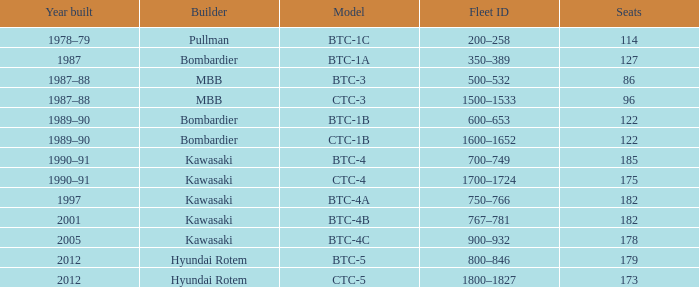For the train built in 2012 with less than 179 seats, what is the Fleet ID? 1800–1827. Would you be able to parse every entry in this table? {'header': ['Year built', 'Builder', 'Model', 'Fleet ID', 'Seats'], 'rows': [['1978–79', 'Pullman', 'BTC-1C', '200–258', '114'], ['1987', 'Bombardier', 'BTC-1A', '350–389', '127'], ['1987–88', 'MBB', 'BTC-3', '500–532', '86'], ['1987–88', 'MBB', 'CTC-3', '1500–1533', '96'], ['1989–90', 'Bombardier', 'BTC-1B', '600–653', '122'], ['1989–90', 'Bombardier', 'CTC-1B', '1600–1652', '122'], ['1990–91', 'Kawasaki', 'BTC-4', '700–749', '185'], ['1990–91', 'Kawasaki', 'CTC-4', '1700–1724', '175'], ['1997', 'Kawasaki', 'BTC-4A', '750–766', '182'], ['2001', 'Kawasaki', 'BTC-4B', '767–781', '182'], ['2005', 'Kawasaki', 'BTC-4C', '900–932', '178'], ['2012', 'Hyundai Rotem', 'BTC-5', '800–846', '179'], ['2012', 'Hyundai Rotem', 'CTC-5', '1800–1827', '173']]} 